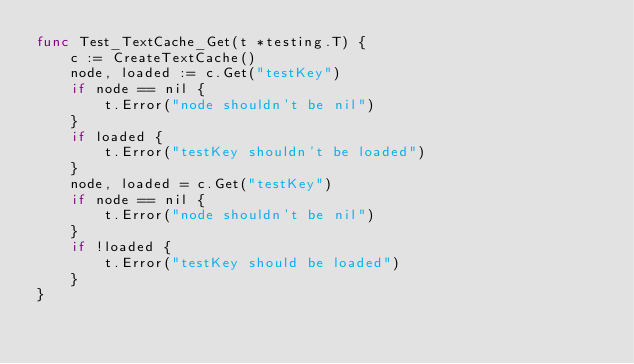<code> <loc_0><loc_0><loc_500><loc_500><_Go_>func Test_TextCache_Get(t *testing.T) {
	c := CreateTextCache()
	node, loaded := c.Get("testKey")
	if node == nil {
		t.Error("node shouldn't be nil")
	}
	if loaded {
		t.Error("testKey shouldn't be loaded")
	}
	node, loaded = c.Get("testKey")
	if node == nil {
		t.Error("node shouldn't be nil")
	}
	if !loaded {
		t.Error("testKey should be loaded")
	}
}
</code> 